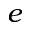Convert formula to latex. <formula><loc_0><loc_0><loc_500><loc_500>e</formula> 